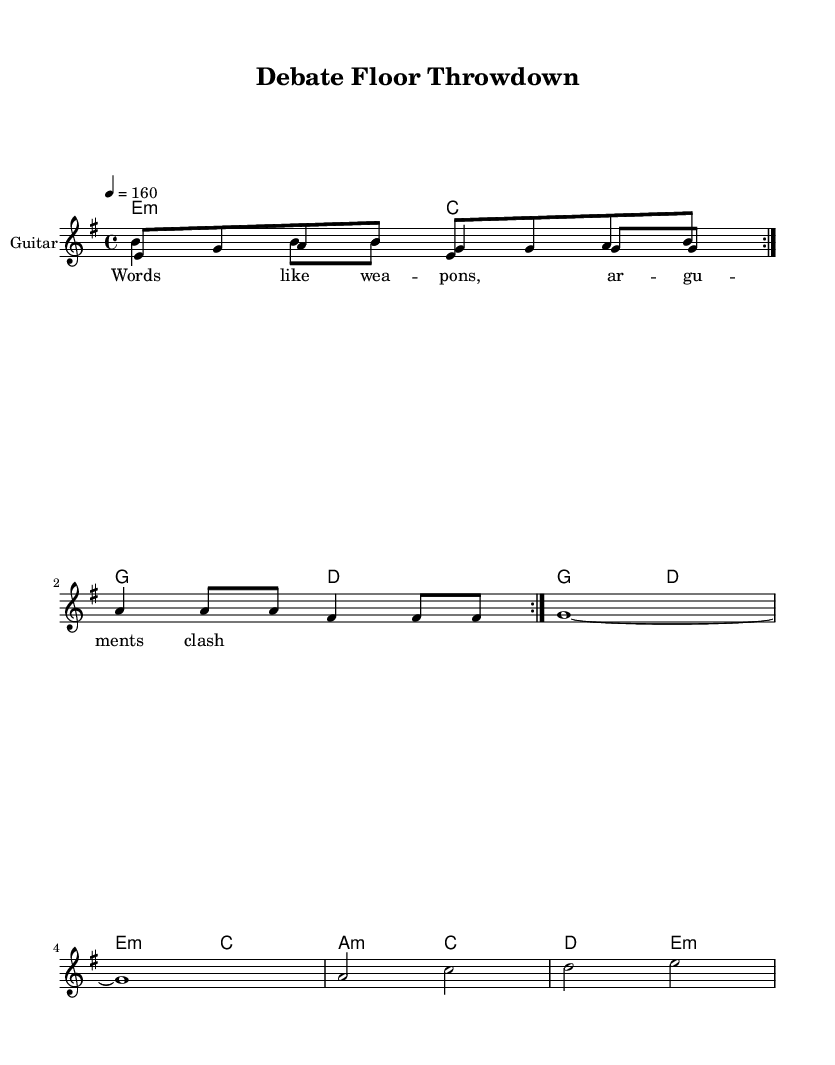What is the key signature of this music? The key signature is E minor, which has one sharp (F#). This is indicated by the `\key e \minor` notation in the music.
Answer: E minor What is the time signature of the piece? The time signature is 4/4, which means there are four beats in each measure and a quarter note gets one beat. This is shown by the `\time 4/4` notation in the score.
Answer: 4/4 What is the tempo marking of the music? The tempo marking is 160 beats per minute, indicated by `\tempo 4 = 160`. This means that each quarter note should be played at a speed of 160 beats in one minute.
Answer: 160 How many measures are in the guitar riff section? The guitar riff section consists of 8 measures, as it repeats twice in the score (`\repeat volta 2`). Each repeat includes a series of notes outlined in the `guitarRiff` section, extracted over 4 measures per repeat.
Answer: 8 What type of chords are primarily used in this piece? The chords used are mostly minor and major chords, specifically E minor, C major, G major, D major, and A minor, forming the harmonic backbone of the piece. This is represented in the chord mode section.
Answer: Minor and major What theme is reflected in the lyrics of the melody? The lyrics reflect themes of rivalry and competition, as indicated by the line "Words like weapons, arguments clash," which suggests conflict and confrontation. This thematic focus aligns with the energetic nature typical of rock music.
Answer: Rivalry 